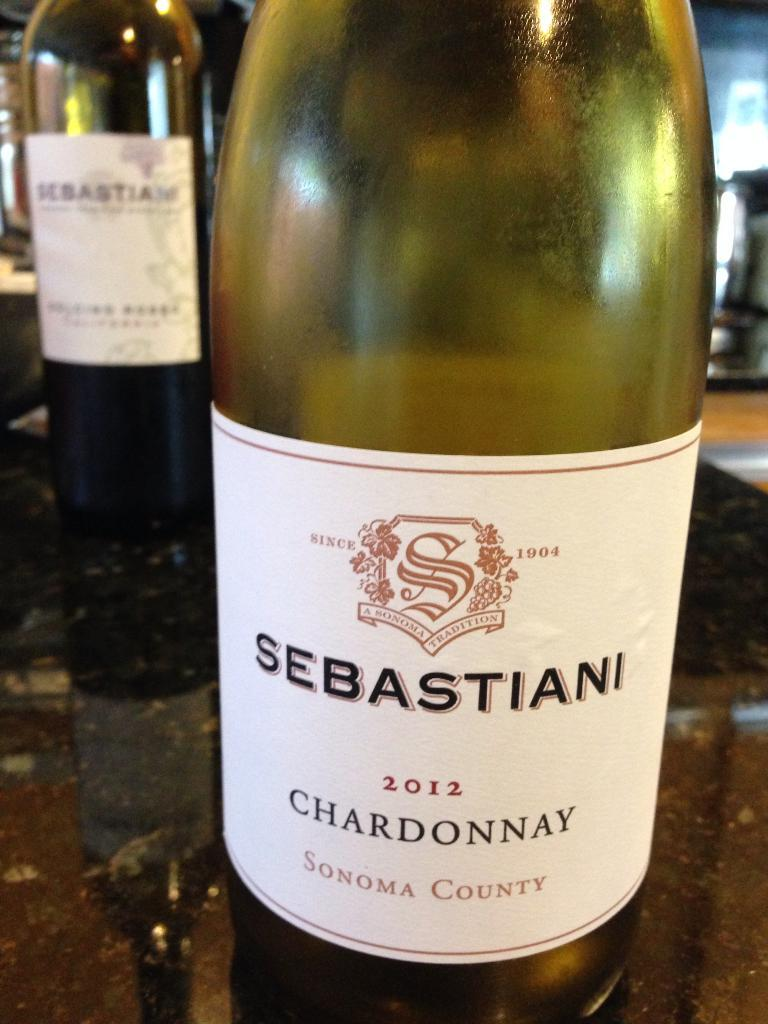Provide a one-sentence caption for the provided image. Green bottle of sebastiani chardonnay sonoma county wine. 